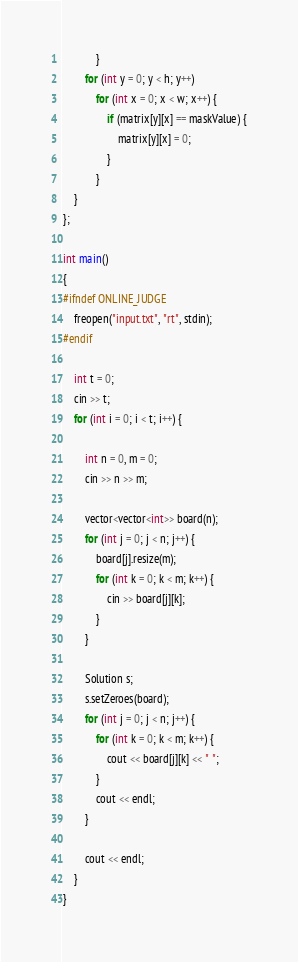<code> <loc_0><loc_0><loc_500><loc_500><_C++_>            }
        for (int y = 0; y < h; y++)
            for (int x = 0; x < w; x++) {
                if (matrix[y][x] == maskValue) {
                    matrix[y][x] = 0;
                }
            }
    }
};

int main()
{
#ifndef ONLINE_JUDGE
    freopen("input.txt", "rt", stdin);
#endif

    int t = 0;
    cin >> t;
    for (int i = 0; i < t; i++) {

        int n = 0, m = 0;
        cin >> n >> m;

        vector<vector<int>> board(n);
        for (int j = 0; j < n; j++) {
            board[j].resize(m);
            for (int k = 0; k < m; k++) {
                cin >> board[j][k];
            }
        }

        Solution s;
        s.setZeroes(board);
        for (int j = 0; j < n; j++) {
            for (int k = 0; k < m; k++) {
                cout << board[j][k] << " ";
            }
            cout << endl;
        }

        cout << endl;
    }
}</code> 